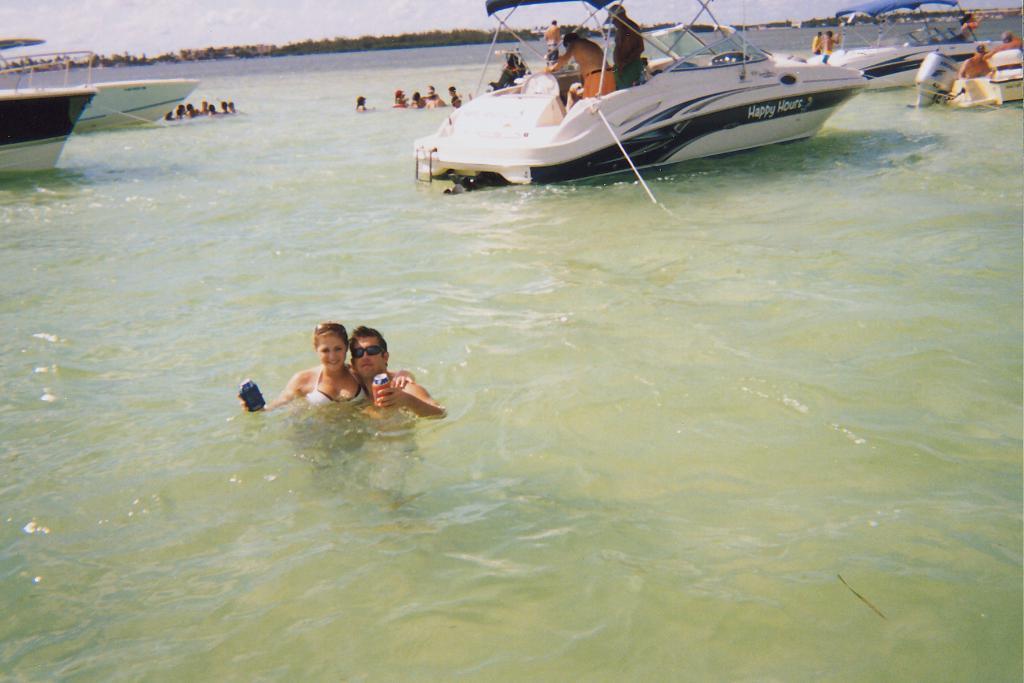Can you describe this image briefly? In this picture there is a man and a woman on the left side of the image, in a swimming pool and there are yachts and other people at the top side of the image. 